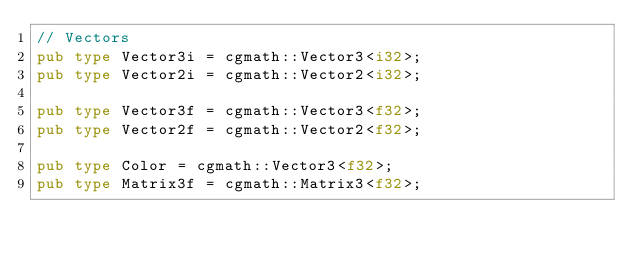Convert code to text. <code><loc_0><loc_0><loc_500><loc_500><_Rust_>// Vectors
pub type Vector3i = cgmath::Vector3<i32>;
pub type Vector2i = cgmath::Vector2<i32>;

pub type Vector3f = cgmath::Vector3<f32>;
pub type Vector2f = cgmath::Vector2<f32>;

pub type Color = cgmath::Vector3<f32>;
pub type Matrix3f = cgmath::Matrix3<f32>;
</code> 